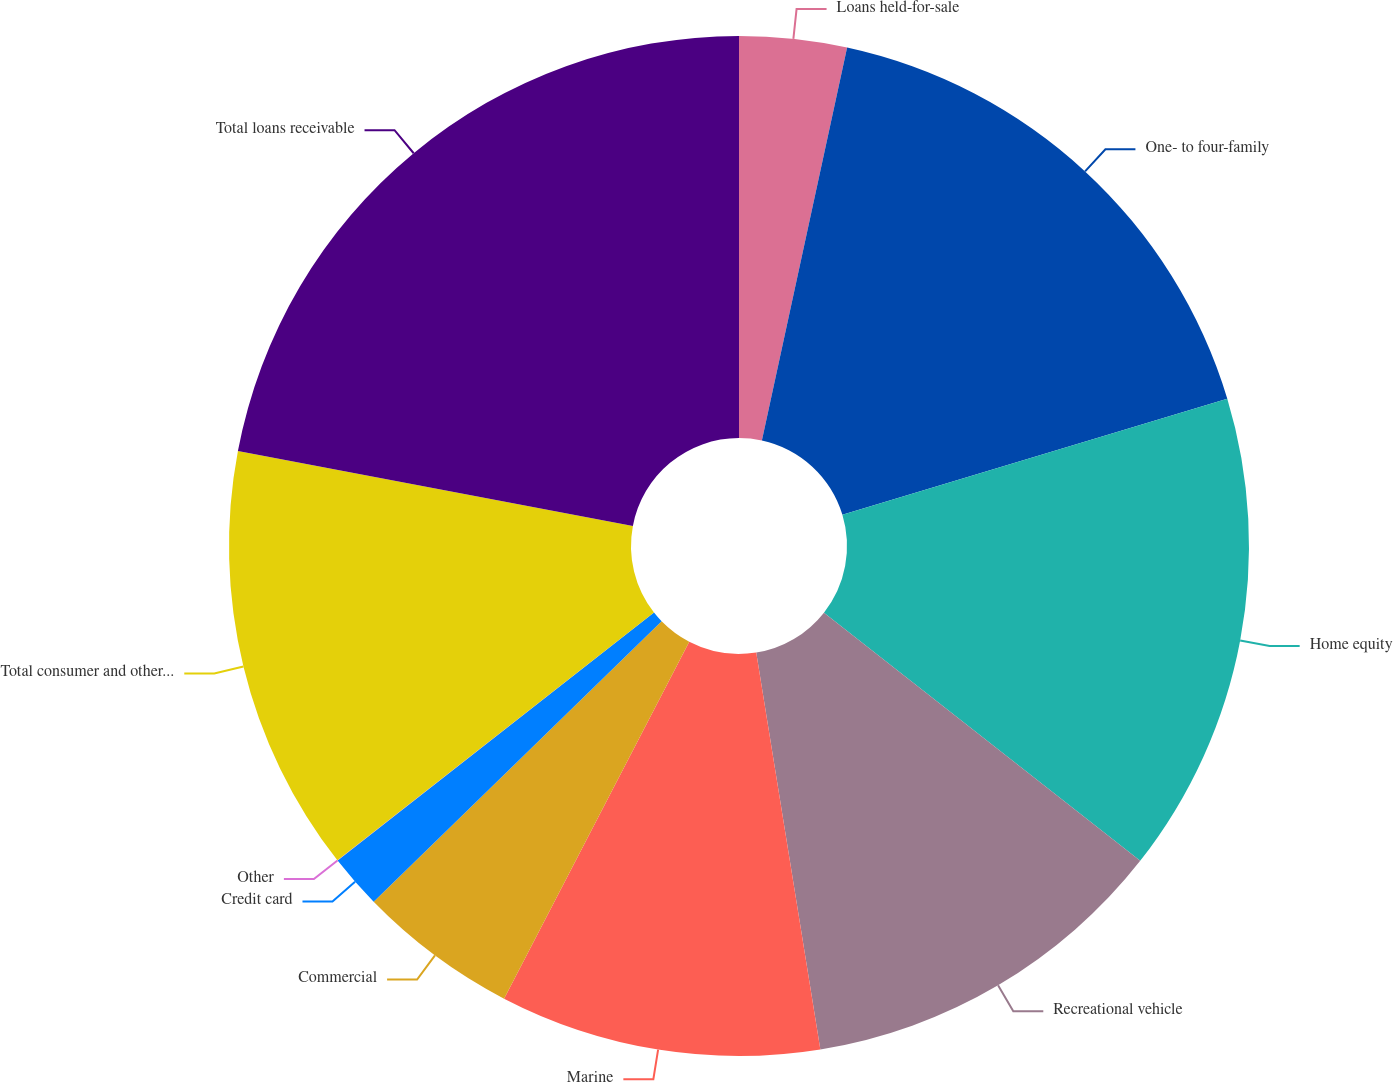Convert chart to OTSL. <chart><loc_0><loc_0><loc_500><loc_500><pie_chart><fcel>Loans held-for-sale<fcel>One- to four-family<fcel>Home equity<fcel>Recreational vehicle<fcel>Marine<fcel>Commercial<fcel>Credit card<fcel>Other<fcel>Total consumer and other loans<fcel>Total loans receivable<nl><fcel>3.4%<fcel>16.94%<fcel>15.25%<fcel>11.86%<fcel>10.17%<fcel>5.09%<fcel>1.71%<fcel>0.01%<fcel>13.55%<fcel>22.02%<nl></chart> 